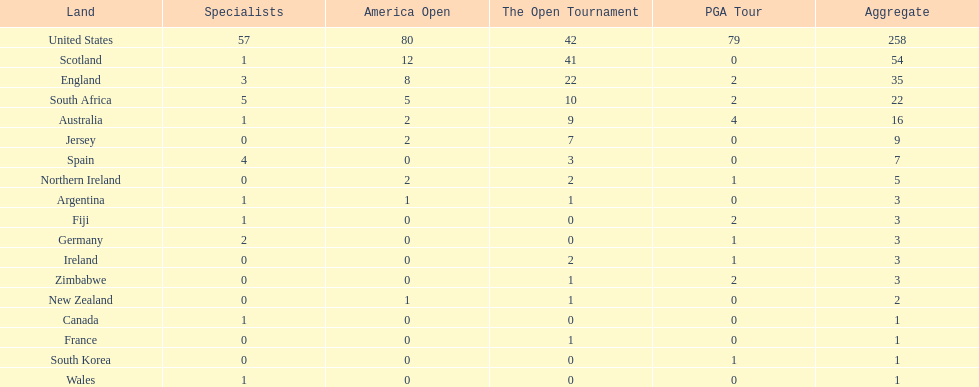Could you parse the entire table as a dict? {'header': ['Land', 'Specialists', 'America Open', 'The Open Tournament', 'PGA Tour', 'Aggregate'], 'rows': [['United States', '57', '80', '42', '79', '258'], ['Scotland', '1', '12', '41', '0', '54'], ['England', '3', '8', '22', '2', '35'], ['South Africa', '5', '5', '10', '2', '22'], ['Australia', '1', '2', '9', '4', '16'], ['Jersey', '0', '2', '7', '0', '9'], ['Spain', '4', '0', '3', '0', '7'], ['Northern Ireland', '0', '2', '2', '1', '5'], ['Argentina', '1', '1', '1', '0', '3'], ['Fiji', '1', '0', '0', '2', '3'], ['Germany', '2', '0', '0', '1', '3'], ['Ireland', '0', '0', '2', '1', '3'], ['Zimbabwe', '0', '0', '1', '2', '3'], ['New Zealand', '0', '1', '1', '0', '2'], ['Canada', '1', '0', '0', '0', '1'], ['France', '0', '0', '1', '0', '1'], ['South Korea', '0', '0', '0', '1', '1'], ['Wales', '1', '0', '0', '0', '1']]} Is the united stated or scotland better? United States. 